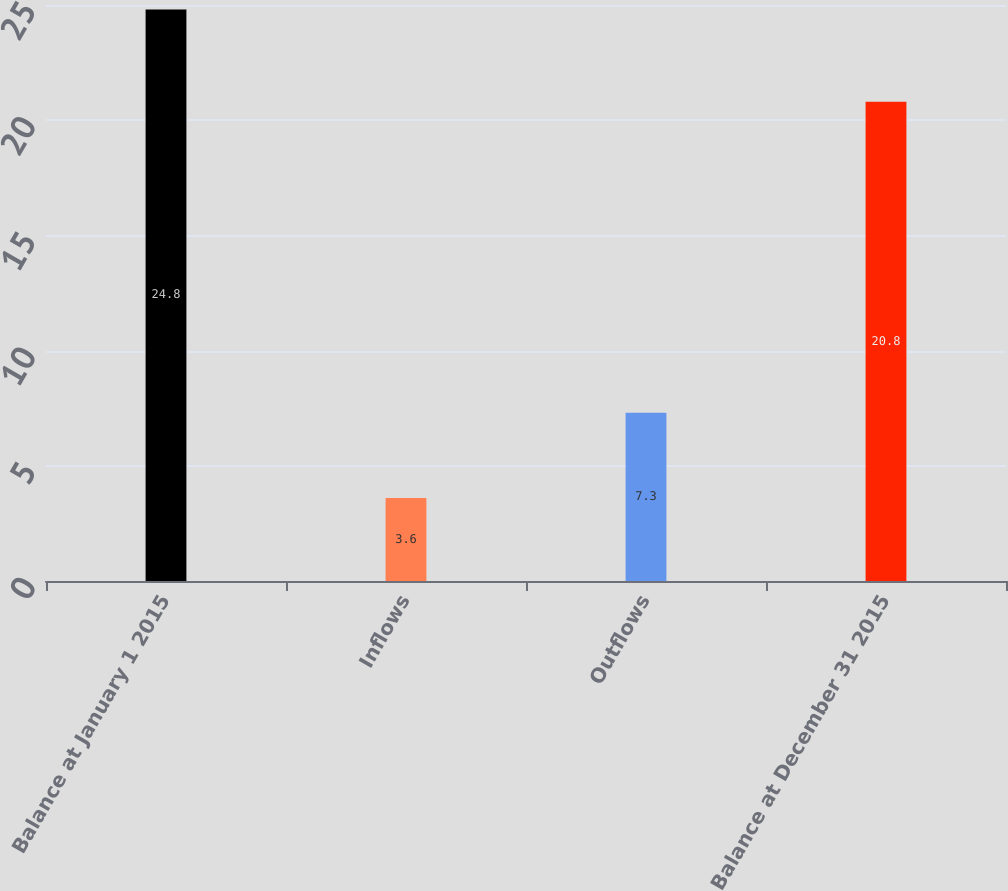Convert chart to OTSL. <chart><loc_0><loc_0><loc_500><loc_500><bar_chart><fcel>Balance at January 1 2015<fcel>Inflows<fcel>Outflows<fcel>Balance at December 31 2015<nl><fcel>24.8<fcel>3.6<fcel>7.3<fcel>20.8<nl></chart> 